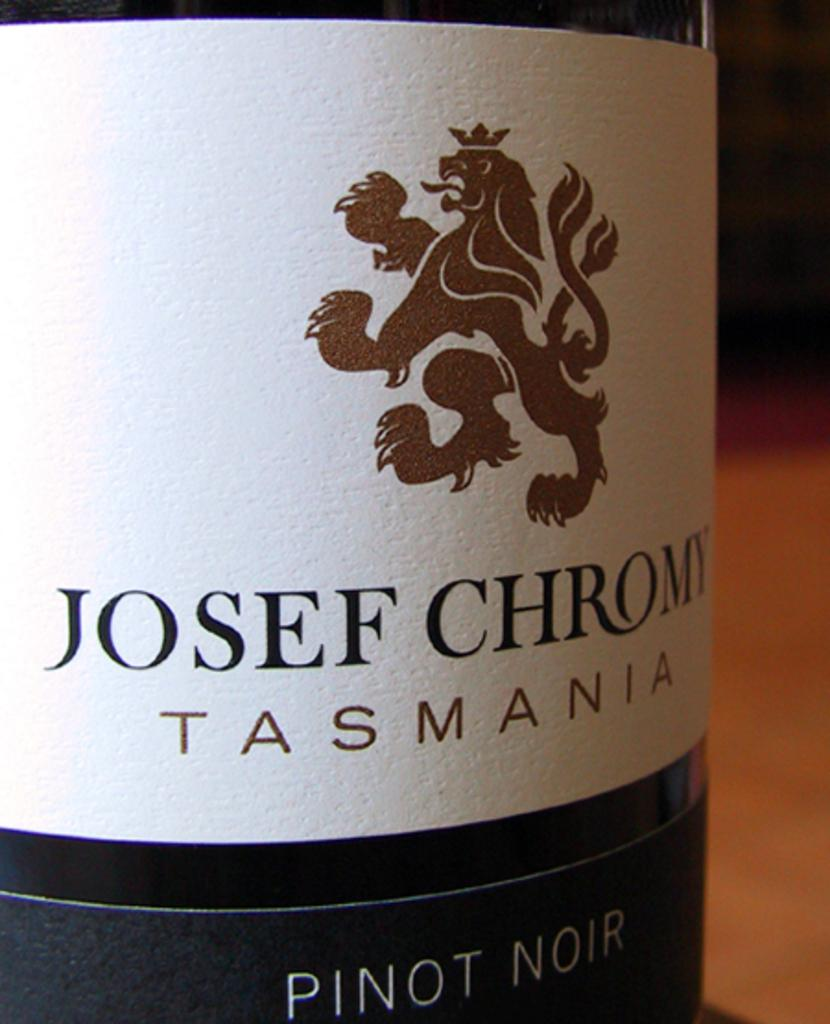What is the main object in the image? There is a wine bottle in the image. Where is the wine bottle located? The wine bottle is on a table. How much does the girl weigh in the image? There is no girl present in the image, so it is not possible to determine her weight. 